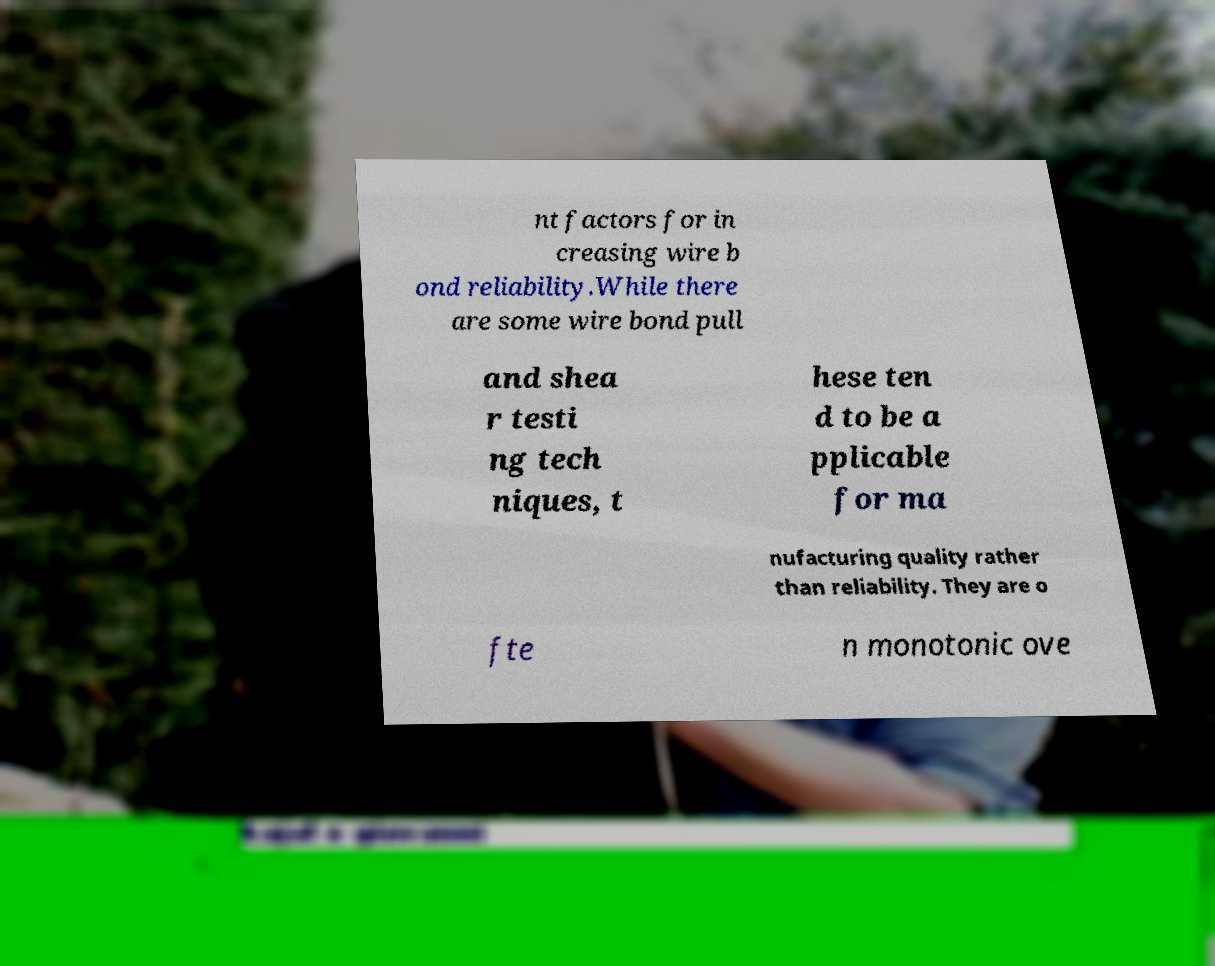Could you assist in decoding the text presented in this image and type it out clearly? nt factors for in creasing wire b ond reliability.While there are some wire bond pull and shea r testi ng tech niques, t hese ten d to be a pplicable for ma nufacturing quality rather than reliability. They are o fte n monotonic ove 